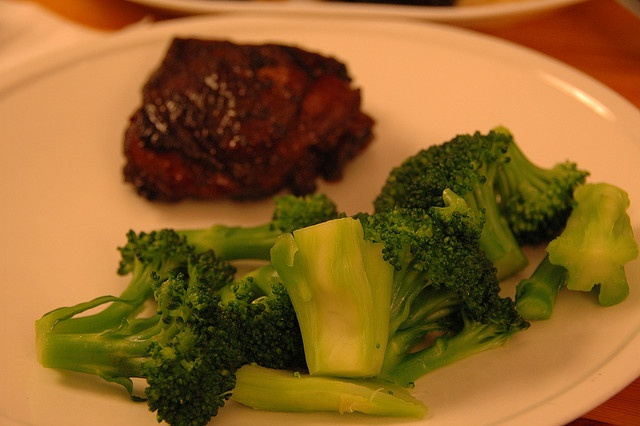Describe the objects in this image and their specific colors. I can see dining table in orange, black, olive, and maroon tones, broccoli in tan, black, olive, and darkgreen tones, broccoli in tan, black, olive, and darkgreen tones, broccoli in tan, olive, and orange tones, and broccoli in tan, olive, and black tones in this image. 